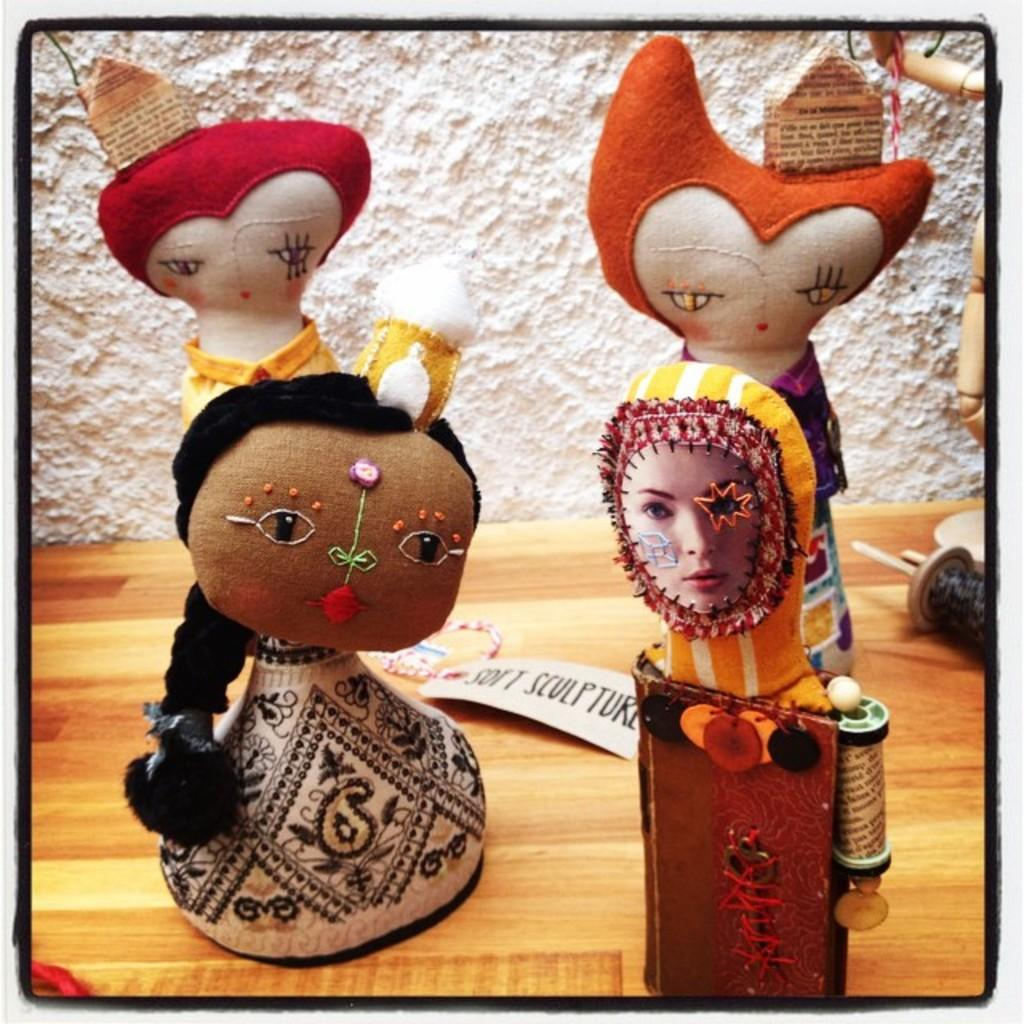What objects are on the table in the image? There are two dolls on the table. What is visible in the background of the image? There is a wall in the background of the image. What type of club does the carpenter use to modify the dolls' behavior in the image? There is no carpenter or club present in the image, and the dolls' behavior is not mentioned. 